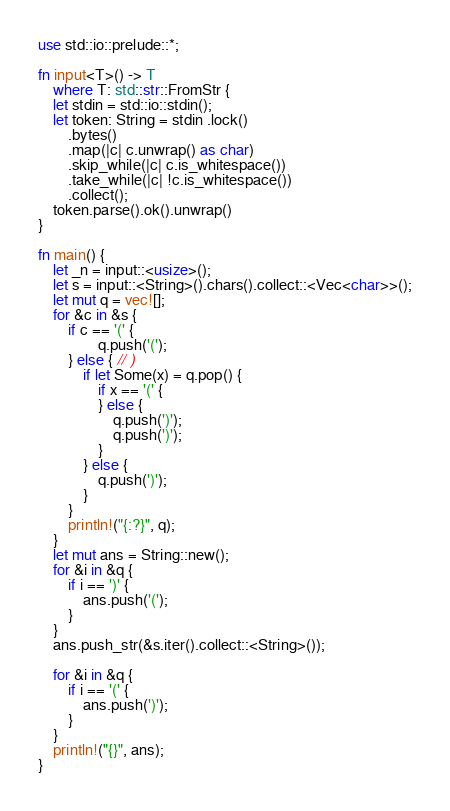<code> <loc_0><loc_0><loc_500><loc_500><_Rust_>use std::io::prelude::*;

fn input<T>() -> T
    where T: std::str::FromStr {
    let stdin = std::io::stdin();
    let token: String = stdin .lock()
        .bytes()
        .map(|c| c.unwrap() as char)
        .skip_while(|c| c.is_whitespace())
        .take_while(|c| !c.is_whitespace())
        .collect();
    token.parse().ok().unwrap()
}

fn main() {
    let _n = input::<usize>();
    let s = input::<String>().chars().collect::<Vec<char>>();
    let mut q = vec![];
    for &c in &s {
        if c == '(' {
                q.push('(');
        } else { // )
            if let Some(x) = q.pop() {
                if x == '(' {
                } else {
                    q.push(')');
                    q.push(')');
                }
            } else {
                q.push(')');
            }
        }
        println!("{:?}", q);
    }
    let mut ans = String::new();
    for &i in &q {
        if i == ')' {
            ans.push('(');
        }
    }
    ans.push_str(&s.iter().collect::<String>());

    for &i in &q {
        if i == '(' {
            ans.push(')');
        }
    }
    println!("{}", ans);
}
</code> 